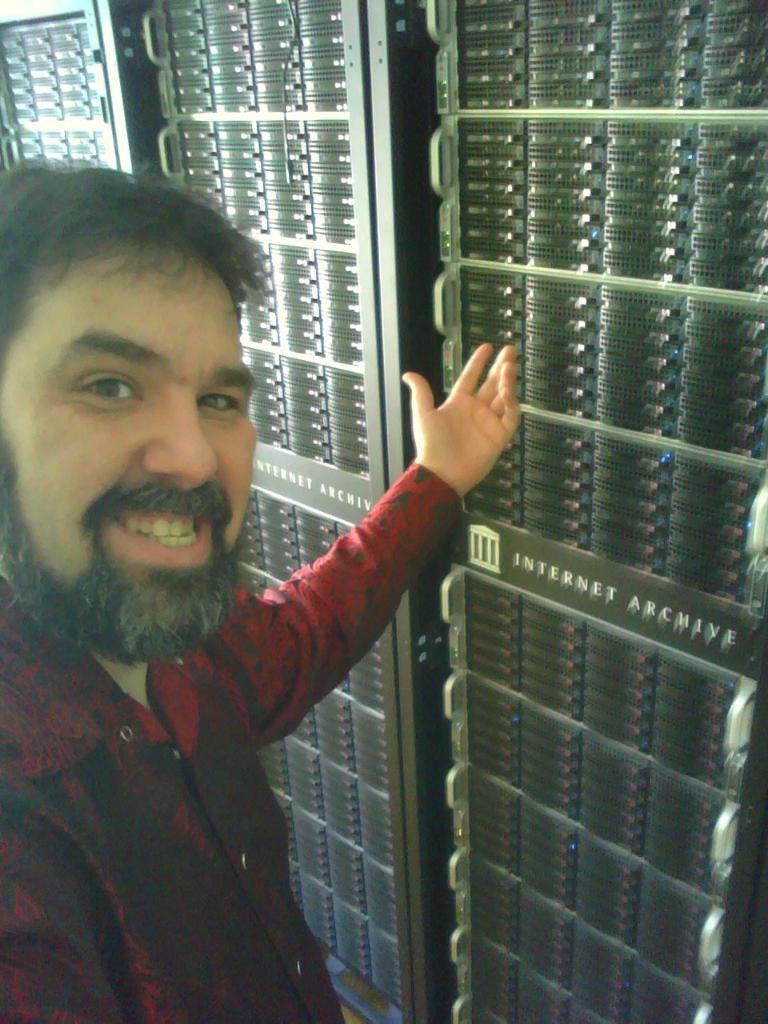Who is present on the left side of the image? There is a person on the left side of the image. What is the person doing in the image? The person is smiling. What can be seen in the background of the image? There are server racks in the background of the image. What type of board is the person holding in the image? There is no board present in the image. Can you see any baskets in the image? There are no baskets visible in the image. 